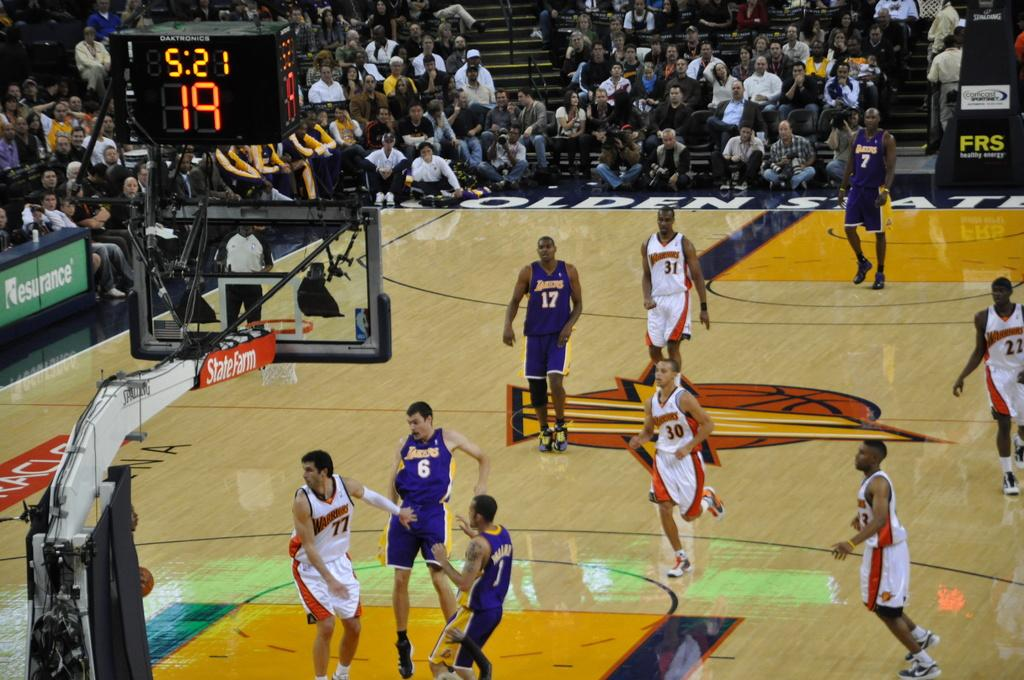Provide a one-sentence caption for the provided image. A State Farm advertisement hangs to the side of a basketball game. 